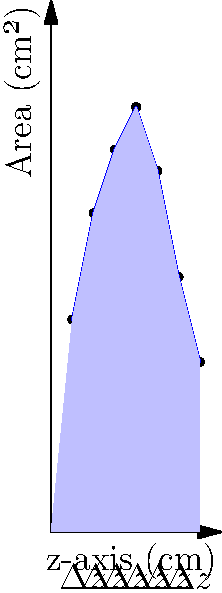As a Swedish physician specializing in medical imaging, you are tasked with calculating the volume of a patient's liver using multiple cross-sectional CT images. The graph shows the cross-sectional areas of the liver at 1 cm intervals along the z-axis. Using the trapezoidal rule, estimate the volume of the liver. Round your answer to the nearest cubic centimeter. To estimate the volume of the liver using the trapezoidal rule, we'll follow these steps:

1) The trapezoidal rule for volume calculation is given by:

   $$V \approx \Delta z \left[\frac{A_0 + A_n}{2} + \sum_{i=1}^{n-1} A_i\right]$$

   where $\Delta z$ is the interval between slices, $A_0$ and $A_n$ are the areas of the first and last slices, and $A_i$ are the areas of the intermediate slices.

2) From the graph, we can see that $\Delta z = 1$ cm and we have 7 slices.

3) The areas (in cm²) are: 10, 15, 18, 20, 17, 12, 8

4) Let's apply the formula:

   $$V \approx 1 \left[\frac{10 + 8}{2} + (15 + 18 + 20 + 17 + 12)\right]$$

5) Simplify:

   $$V \approx 1 [9 + 82]$$
   $$V \approx 91 \text{ cm}^3$$

6) Rounding to the nearest cubic centimeter:

   $$V \approx 91 \text{ cm}^3$$

Thus, the estimated volume of the liver is 91 cm³.
Answer: 91 cm³ 